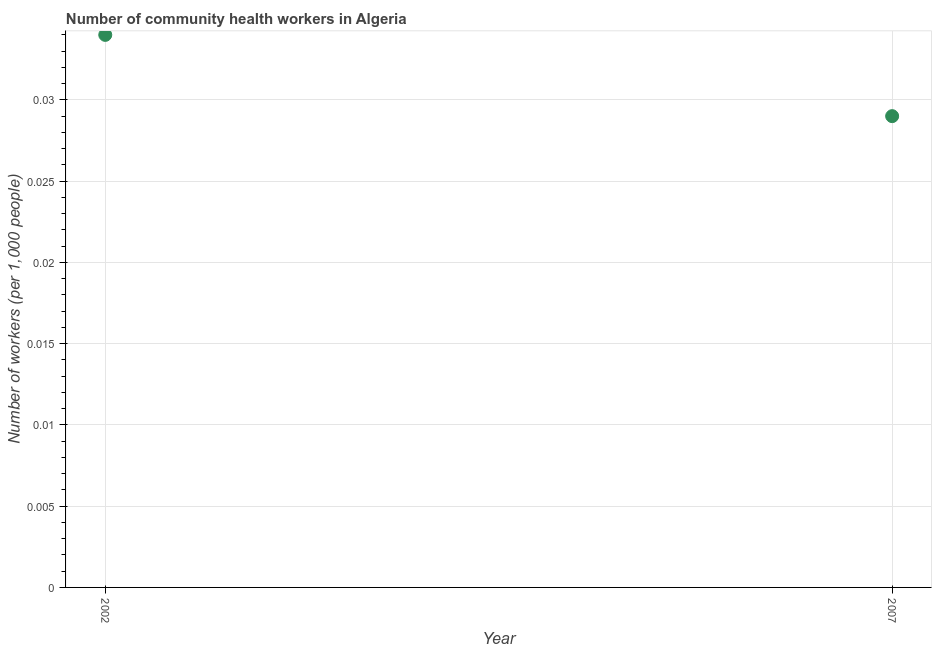What is the number of community health workers in 2007?
Make the answer very short. 0.03. Across all years, what is the maximum number of community health workers?
Make the answer very short. 0.03. Across all years, what is the minimum number of community health workers?
Offer a terse response. 0.03. In which year was the number of community health workers maximum?
Offer a very short reply. 2002. In which year was the number of community health workers minimum?
Offer a terse response. 2007. What is the sum of the number of community health workers?
Your answer should be very brief. 0.06. What is the difference between the number of community health workers in 2002 and 2007?
Ensure brevity in your answer.  0.01. What is the average number of community health workers per year?
Offer a very short reply. 0.03. What is the median number of community health workers?
Ensure brevity in your answer.  0.03. What is the ratio of the number of community health workers in 2002 to that in 2007?
Your answer should be compact. 1.17. In how many years, is the number of community health workers greater than the average number of community health workers taken over all years?
Provide a short and direct response. 1. Does the number of community health workers monotonically increase over the years?
Make the answer very short. No. How many years are there in the graph?
Provide a succinct answer. 2. What is the difference between two consecutive major ticks on the Y-axis?
Ensure brevity in your answer.  0.01. What is the title of the graph?
Provide a short and direct response. Number of community health workers in Algeria. What is the label or title of the X-axis?
Your response must be concise. Year. What is the label or title of the Y-axis?
Give a very brief answer. Number of workers (per 1,0 people). What is the Number of workers (per 1,000 people) in 2002?
Offer a very short reply. 0.03. What is the Number of workers (per 1,000 people) in 2007?
Provide a succinct answer. 0.03. What is the difference between the Number of workers (per 1,000 people) in 2002 and 2007?
Offer a very short reply. 0.01. What is the ratio of the Number of workers (per 1,000 people) in 2002 to that in 2007?
Provide a succinct answer. 1.17. 